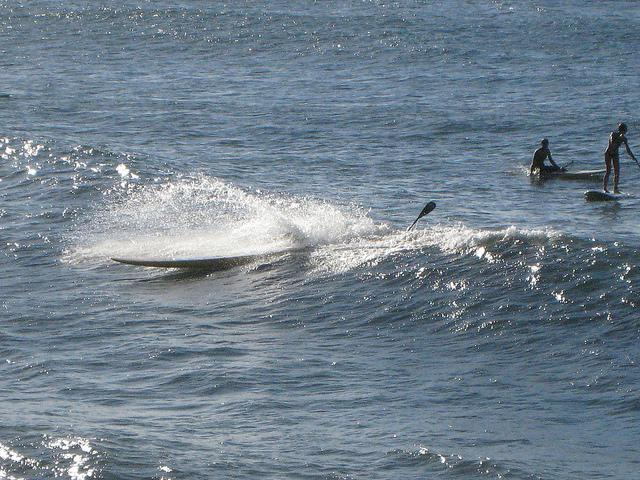What is below the paddle shown here? Please explain your reasoning. person. The person below the paddle is likely a human submerged in water. 